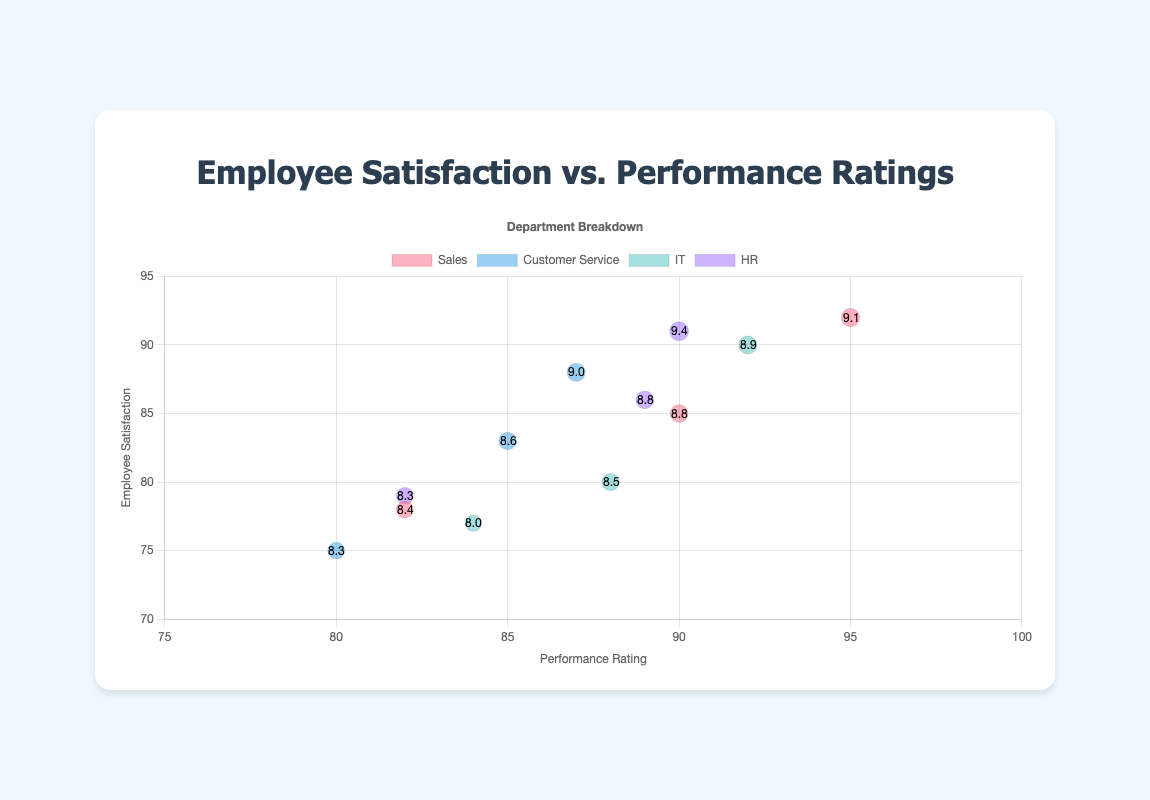What departments are represented in the chart? The chart label colors indicate four departments: Sales (red), Customer Service (blue), IT (green), and HR (purple).
Answer: Sales, Customer Service, IT, HR Which department has the bubble with the highest employee satisfaction rating? The highest employee satisfaction rating is seen in the Sales department, represented by an almost transparent red bubble at Satisfaction = 92.
Answer: Sales What is the reliability score for the employee with the highest employee satisfaction rating? The bubble size, representing reliability, for the employee with the highest satisfaction rating (92) is approximately '9.1'. Hence, this employee's reliability score is 91.
Answer: 91 How does the performance rating of the IT department's highest satisfaction employee compare to that of the Customer Service department's highest satisfaction employee? The highest satisfaction employees in IT have a satisfaction rating of 90 and a performance rating of 92. For Customer Service, the highest satisfaction (88) has a performance rating of 87. Thus, the performance rating in IT is higher.
Answer: IT has higher performance Which employee has a performance rating of 95? The performance rating of 95 appears in the Sales department bubble, indicating the employee named Michael Johnson.
Answer: Michael Johnson Are there any departments where the highest performance rating is equal to the highest employee satisfaction rating? The highest performance and satisfaction ratings overlap for the HR department with a rating of 90. This is depicted by a purple bubble at (90, 90).
Answer: HR What is the average performance rating for the HR department? HR’s ratings are 89, 82, and 90. The sum is 261, so the average is 261 / 3 = 87.
Answer: 87 How many employees from the IT department have a satisfaction rating below 80? The IT department has one employee below a satisfaction rating of 80 - Robert Anderson with a rating of 77.
Answer: 1 Is there a direct correlation between performance rating and employee satisfaction in the Customer Service department? Observing the blue bubbles for Customer Service, no strong positive or negative trend is obvious between performance and satisfaction from the scattered placements.
Answer: No strong correlation Which two employees have nearly equal satisfaction and reliability scores in the HR department? For HR, similar bubbles for satisfaction (~90) and reliability (~90) are Barbara White and Mary Thomas, indicating similar scores.
Answer: Barbara White, Mary Thomas 